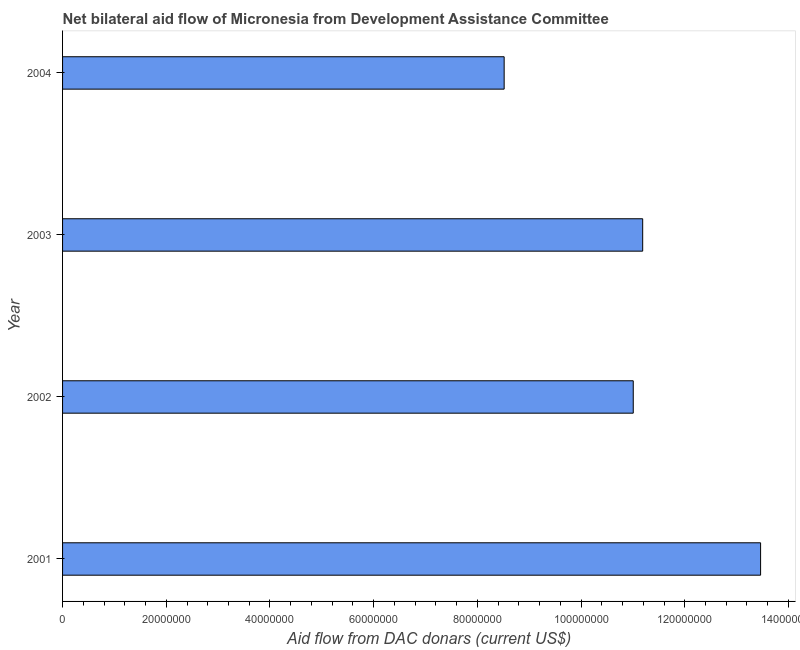Does the graph contain grids?
Provide a short and direct response. No. What is the title of the graph?
Give a very brief answer. Net bilateral aid flow of Micronesia from Development Assistance Committee. What is the label or title of the X-axis?
Make the answer very short. Aid flow from DAC donars (current US$). What is the net bilateral aid flows from dac donors in 2004?
Give a very brief answer. 8.52e+07. Across all years, what is the maximum net bilateral aid flows from dac donors?
Offer a very short reply. 1.35e+08. Across all years, what is the minimum net bilateral aid flows from dac donors?
Your answer should be compact. 8.52e+07. In which year was the net bilateral aid flows from dac donors minimum?
Give a very brief answer. 2004. What is the sum of the net bilateral aid flows from dac donors?
Your answer should be very brief. 4.42e+08. What is the difference between the net bilateral aid flows from dac donors in 2001 and 2004?
Your answer should be very brief. 4.95e+07. What is the average net bilateral aid flows from dac donors per year?
Make the answer very short. 1.10e+08. What is the median net bilateral aid flows from dac donors?
Your answer should be very brief. 1.11e+08. What is the ratio of the net bilateral aid flows from dac donors in 2003 to that in 2004?
Make the answer very short. 1.31. Is the net bilateral aid flows from dac donors in 2002 less than that in 2004?
Your answer should be compact. No. What is the difference between the highest and the second highest net bilateral aid flows from dac donors?
Your answer should be compact. 2.27e+07. Is the sum of the net bilateral aid flows from dac donors in 2002 and 2003 greater than the maximum net bilateral aid flows from dac donors across all years?
Keep it short and to the point. Yes. What is the difference between the highest and the lowest net bilateral aid flows from dac donors?
Your answer should be compact. 4.95e+07. How many bars are there?
Make the answer very short. 4. Are all the bars in the graph horizontal?
Provide a succinct answer. Yes. What is the Aid flow from DAC donars (current US$) of 2001?
Keep it short and to the point. 1.35e+08. What is the Aid flow from DAC donars (current US$) of 2002?
Your answer should be very brief. 1.10e+08. What is the Aid flow from DAC donars (current US$) of 2003?
Ensure brevity in your answer.  1.12e+08. What is the Aid flow from DAC donars (current US$) of 2004?
Your answer should be compact. 8.52e+07. What is the difference between the Aid flow from DAC donars (current US$) in 2001 and 2002?
Your answer should be very brief. 2.46e+07. What is the difference between the Aid flow from DAC donars (current US$) in 2001 and 2003?
Make the answer very short. 2.27e+07. What is the difference between the Aid flow from DAC donars (current US$) in 2001 and 2004?
Give a very brief answer. 4.95e+07. What is the difference between the Aid flow from DAC donars (current US$) in 2002 and 2003?
Ensure brevity in your answer.  -1.82e+06. What is the difference between the Aid flow from DAC donars (current US$) in 2002 and 2004?
Your answer should be compact. 2.49e+07. What is the difference between the Aid flow from DAC donars (current US$) in 2003 and 2004?
Offer a very short reply. 2.67e+07. What is the ratio of the Aid flow from DAC donars (current US$) in 2001 to that in 2002?
Offer a very short reply. 1.22. What is the ratio of the Aid flow from DAC donars (current US$) in 2001 to that in 2003?
Offer a terse response. 1.2. What is the ratio of the Aid flow from DAC donars (current US$) in 2001 to that in 2004?
Give a very brief answer. 1.58. What is the ratio of the Aid flow from DAC donars (current US$) in 2002 to that in 2004?
Make the answer very short. 1.29. What is the ratio of the Aid flow from DAC donars (current US$) in 2003 to that in 2004?
Offer a terse response. 1.31. 